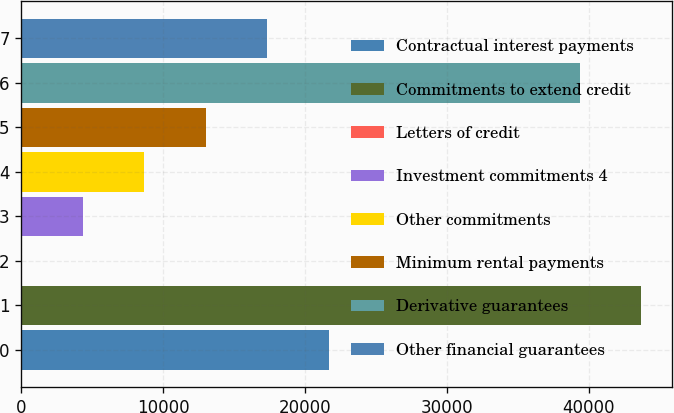<chart> <loc_0><loc_0><loc_500><loc_500><bar_chart><fcel>Contractual interest payments<fcel>Commitments to extend credit<fcel>Letters of credit<fcel>Investment commitments 4<fcel>Other commitments<fcel>Minimum rental payments<fcel>Derivative guarantees<fcel>Other financial guarantees<nl><fcel>21683<fcel>43701.6<fcel>10<fcel>4344.6<fcel>8679.2<fcel>13013.8<fcel>39367<fcel>17348.4<nl></chart> 